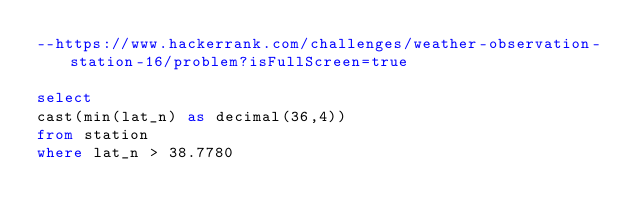<code> <loc_0><loc_0><loc_500><loc_500><_SQL_>--https://www.hackerrank.com/challenges/weather-observation-station-16/problem?isFullScreen=true

select 
cast(min(lat_n) as decimal(36,4))
from station 
where lat_n > 38.7780
</code> 